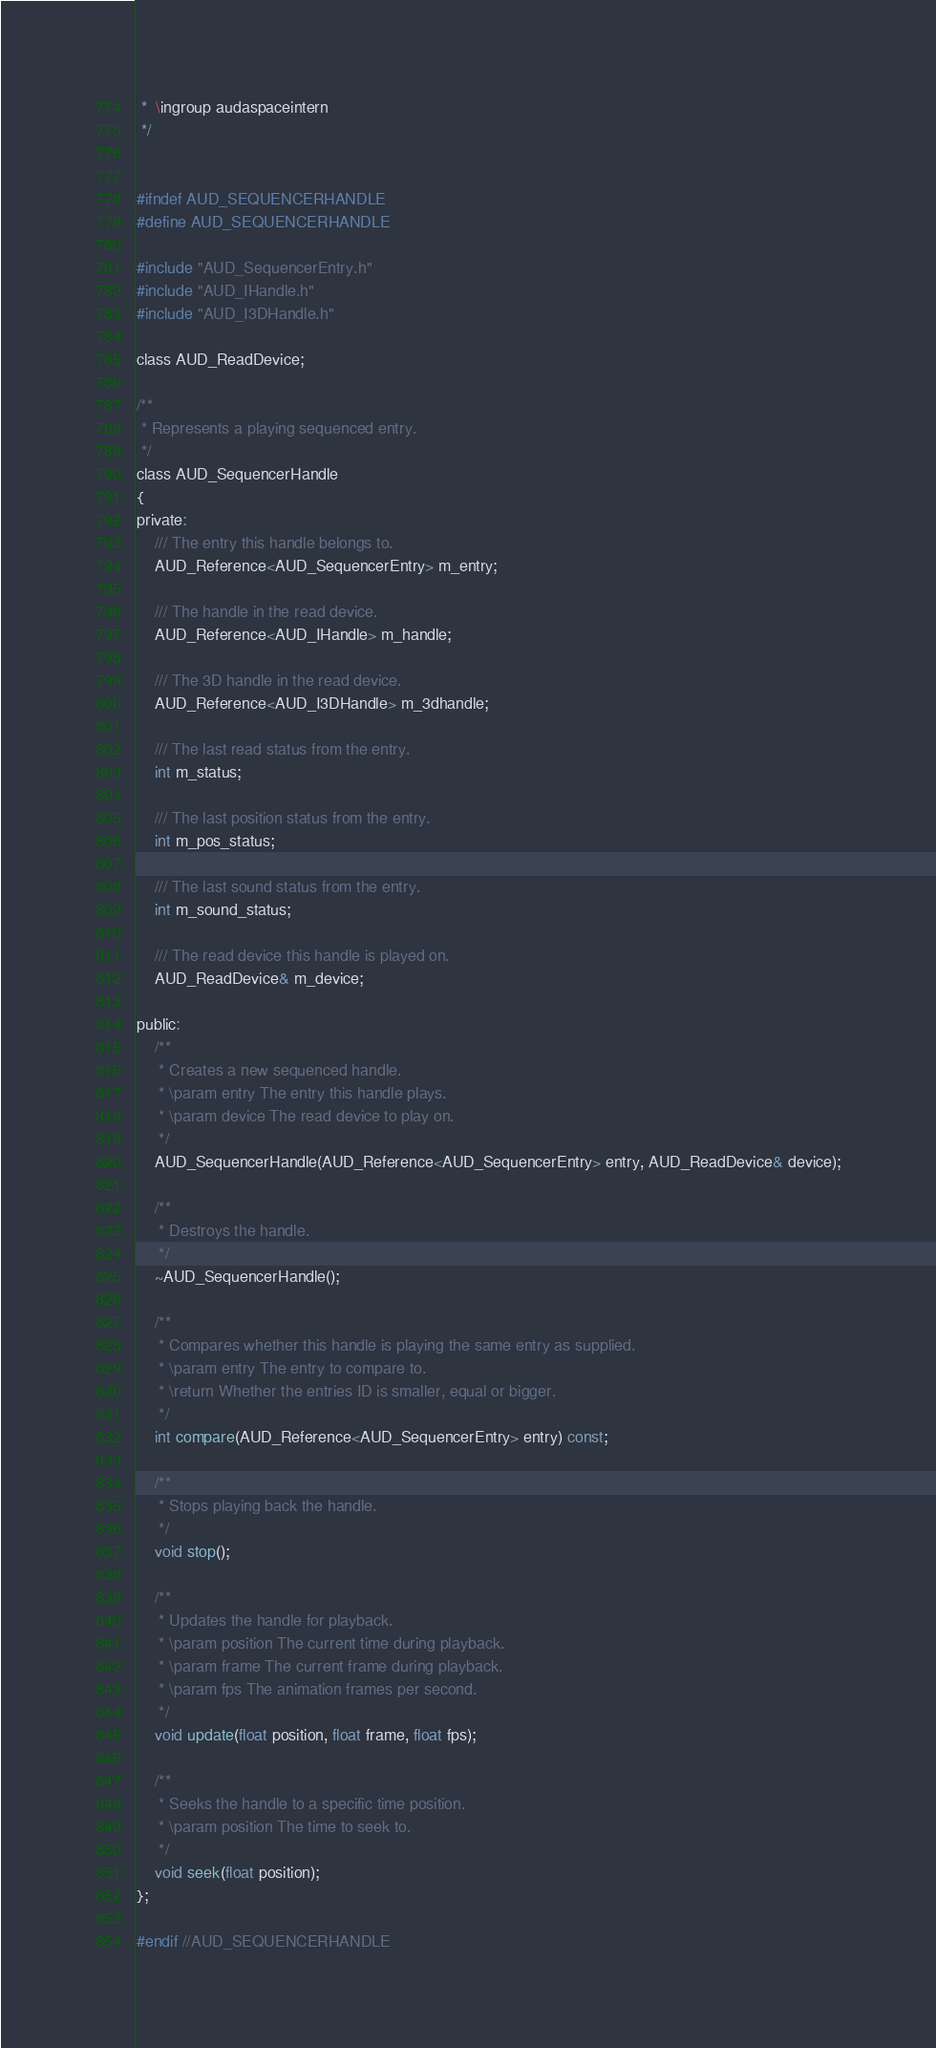Convert code to text. <code><loc_0><loc_0><loc_500><loc_500><_C_> *  \ingroup audaspaceintern
 */


#ifndef AUD_SEQUENCERHANDLE
#define AUD_SEQUENCERHANDLE

#include "AUD_SequencerEntry.h"
#include "AUD_IHandle.h"
#include "AUD_I3DHandle.h"

class AUD_ReadDevice;

/**
 * Represents a playing sequenced entry.
 */
class AUD_SequencerHandle
{
private:
	/// The entry this handle belongs to.
	AUD_Reference<AUD_SequencerEntry> m_entry;

	/// The handle in the read device.
	AUD_Reference<AUD_IHandle> m_handle;

	/// The 3D handle in the read device.
	AUD_Reference<AUD_I3DHandle> m_3dhandle;

	/// The last read status from the entry.
	int m_status;

	/// The last position status from the entry.
	int m_pos_status;

	/// The last sound status from the entry.
	int m_sound_status;

	/// The read device this handle is played on.
	AUD_ReadDevice& m_device;

public:
	/**
	 * Creates a new sequenced handle.
	 * \param entry The entry this handle plays.
	 * \param device The read device to play on.
	 */
	AUD_SequencerHandle(AUD_Reference<AUD_SequencerEntry> entry, AUD_ReadDevice& device);

	/**
	 * Destroys the handle.
	 */
	~AUD_SequencerHandle();

	/**
	 * Compares whether this handle is playing the same entry as supplied.
	 * \param entry The entry to compare to.
	 * \return Whether the entries ID is smaller, equal or bigger.
	 */
	int compare(AUD_Reference<AUD_SequencerEntry> entry) const;

	/**
	 * Stops playing back the handle.
	 */
	void stop();

	/**
	 * Updates the handle for playback.
	 * \param position The current time during playback.
	 * \param frame The current frame during playback.
	 * \param fps The animation frames per second.
	 */
	void update(float position, float frame, float fps);

	/**
	 * Seeks the handle to a specific time position.
	 * \param position The time to seek to.
	 */
	void seek(float position);
};

#endif //AUD_SEQUENCERHANDLE
</code> 